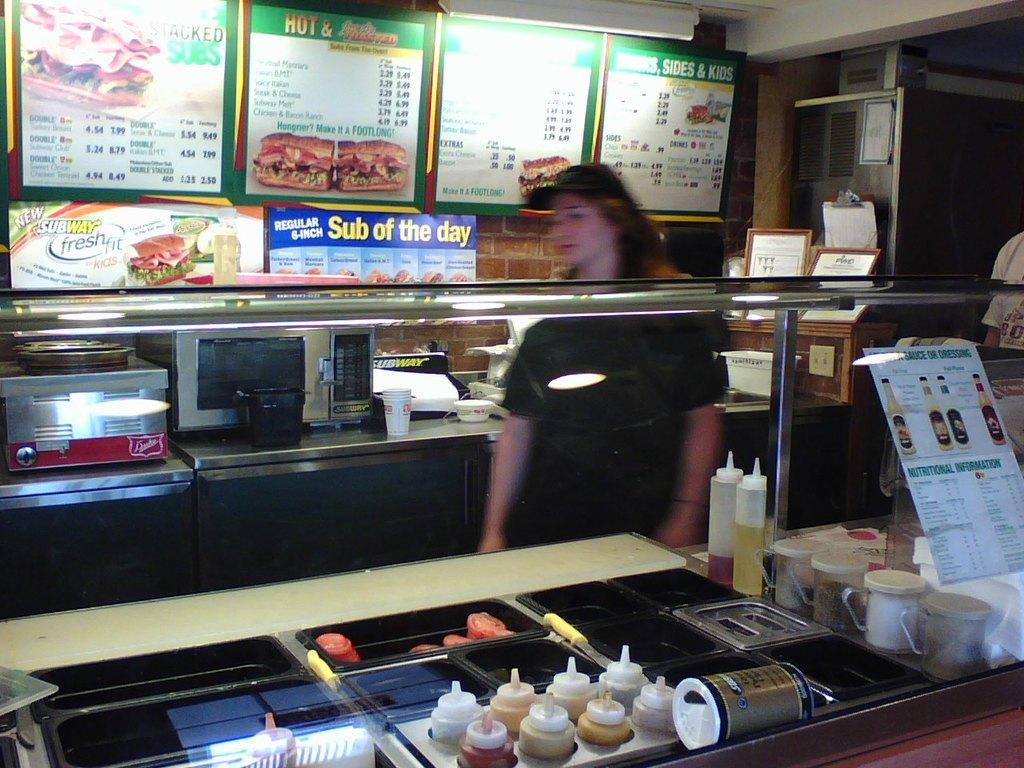Provide a one-sentence caption for the provided image. a subway store with a female employee working. 